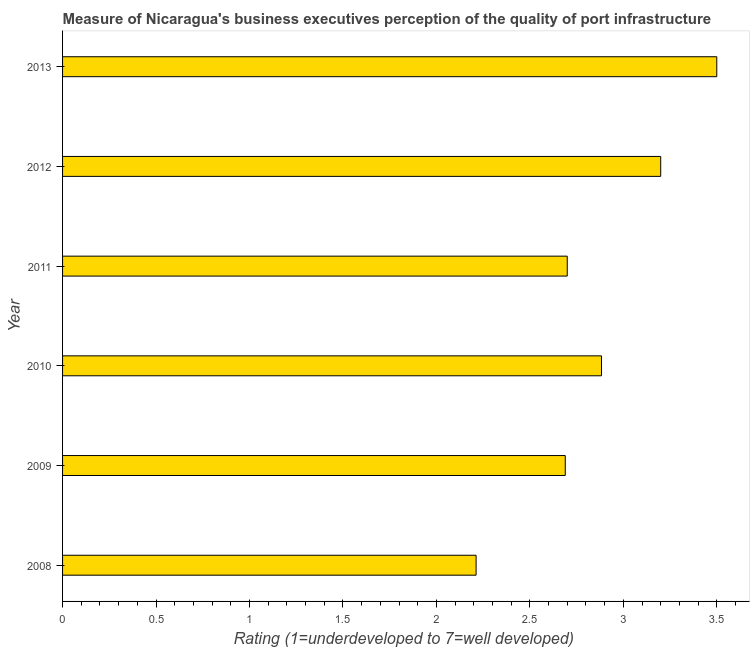Does the graph contain any zero values?
Offer a very short reply. No. What is the title of the graph?
Make the answer very short. Measure of Nicaragua's business executives perception of the quality of port infrastructure. What is the label or title of the X-axis?
Offer a terse response. Rating (1=underdeveloped to 7=well developed) . What is the label or title of the Y-axis?
Provide a short and direct response. Year. What is the rating measuring quality of port infrastructure in 2009?
Keep it short and to the point. 2.69. Across all years, what is the minimum rating measuring quality of port infrastructure?
Keep it short and to the point. 2.21. What is the sum of the rating measuring quality of port infrastructure?
Give a very brief answer. 17.18. What is the difference between the rating measuring quality of port infrastructure in 2008 and 2011?
Keep it short and to the point. -0.49. What is the average rating measuring quality of port infrastructure per year?
Provide a short and direct response. 2.86. What is the median rating measuring quality of port infrastructure?
Offer a terse response. 2.79. What is the ratio of the rating measuring quality of port infrastructure in 2009 to that in 2012?
Provide a short and direct response. 0.84. Is the difference between the rating measuring quality of port infrastructure in 2010 and 2013 greater than the difference between any two years?
Offer a very short reply. No. What is the difference between the highest and the second highest rating measuring quality of port infrastructure?
Provide a short and direct response. 0.3. Is the sum of the rating measuring quality of port infrastructure in 2010 and 2013 greater than the maximum rating measuring quality of port infrastructure across all years?
Keep it short and to the point. Yes. What is the difference between the highest and the lowest rating measuring quality of port infrastructure?
Your response must be concise. 1.29. How many years are there in the graph?
Offer a very short reply. 6. What is the Rating (1=underdeveloped to 7=well developed)  in 2008?
Give a very brief answer. 2.21. What is the Rating (1=underdeveloped to 7=well developed)  of 2009?
Your answer should be very brief. 2.69. What is the Rating (1=underdeveloped to 7=well developed)  of 2010?
Ensure brevity in your answer.  2.88. What is the Rating (1=underdeveloped to 7=well developed)  in 2013?
Ensure brevity in your answer.  3.5. What is the difference between the Rating (1=underdeveloped to 7=well developed)  in 2008 and 2009?
Provide a succinct answer. -0.48. What is the difference between the Rating (1=underdeveloped to 7=well developed)  in 2008 and 2010?
Give a very brief answer. -0.67. What is the difference between the Rating (1=underdeveloped to 7=well developed)  in 2008 and 2011?
Provide a succinct answer. -0.49. What is the difference between the Rating (1=underdeveloped to 7=well developed)  in 2008 and 2012?
Your answer should be compact. -0.99. What is the difference between the Rating (1=underdeveloped to 7=well developed)  in 2008 and 2013?
Make the answer very short. -1.29. What is the difference between the Rating (1=underdeveloped to 7=well developed)  in 2009 and 2010?
Offer a terse response. -0.19. What is the difference between the Rating (1=underdeveloped to 7=well developed)  in 2009 and 2011?
Provide a short and direct response. -0.01. What is the difference between the Rating (1=underdeveloped to 7=well developed)  in 2009 and 2012?
Make the answer very short. -0.51. What is the difference between the Rating (1=underdeveloped to 7=well developed)  in 2009 and 2013?
Offer a very short reply. -0.81. What is the difference between the Rating (1=underdeveloped to 7=well developed)  in 2010 and 2011?
Provide a succinct answer. 0.18. What is the difference between the Rating (1=underdeveloped to 7=well developed)  in 2010 and 2012?
Your response must be concise. -0.32. What is the difference between the Rating (1=underdeveloped to 7=well developed)  in 2010 and 2013?
Provide a short and direct response. -0.62. What is the difference between the Rating (1=underdeveloped to 7=well developed)  in 2011 and 2012?
Provide a succinct answer. -0.5. What is the difference between the Rating (1=underdeveloped to 7=well developed)  in 2012 and 2013?
Offer a terse response. -0.3. What is the ratio of the Rating (1=underdeveloped to 7=well developed)  in 2008 to that in 2009?
Offer a terse response. 0.82. What is the ratio of the Rating (1=underdeveloped to 7=well developed)  in 2008 to that in 2010?
Your response must be concise. 0.77. What is the ratio of the Rating (1=underdeveloped to 7=well developed)  in 2008 to that in 2011?
Offer a terse response. 0.82. What is the ratio of the Rating (1=underdeveloped to 7=well developed)  in 2008 to that in 2012?
Your response must be concise. 0.69. What is the ratio of the Rating (1=underdeveloped to 7=well developed)  in 2008 to that in 2013?
Offer a terse response. 0.63. What is the ratio of the Rating (1=underdeveloped to 7=well developed)  in 2009 to that in 2010?
Your answer should be compact. 0.93. What is the ratio of the Rating (1=underdeveloped to 7=well developed)  in 2009 to that in 2011?
Give a very brief answer. 1. What is the ratio of the Rating (1=underdeveloped to 7=well developed)  in 2009 to that in 2012?
Ensure brevity in your answer.  0.84. What is the ratio of the Rating (1=underdeveloped to 7=well developed)  in 2009 to that in 2013?
Your response must be concise. 0.77. What is the ratio of the Rating (1=underdeveloped to 7=well developed)  in 2010 to that in 2011?
Your answer should be very brief. 1.07. What is the ratio of the Rating (1=underdeveloped to 7=well developed)  in 2010 to that in 2012?
Ensure brevity in your answer.  0.9. What is the ratio of the Rating (1=underdeveloped to 7=well developed)  in 2010 to that in 2013?
Your response must be concise. 0.82. What is the ratio of the Rating (1=underdeveloped to 7=well developed)  in 2011 to that in 2012?
Ensure brevity in your answer.  0.84. What is the ratio of the Rating (1=underdeveloped to 7=well developed)  in 2011 to that in 2013?
Provide a short and direct response. 0.77. What is the ratio of the Rating (1=underdeveloped to 7=well developed)  in 2012 to that in 2013?
Offer a terse response. 0.91. 